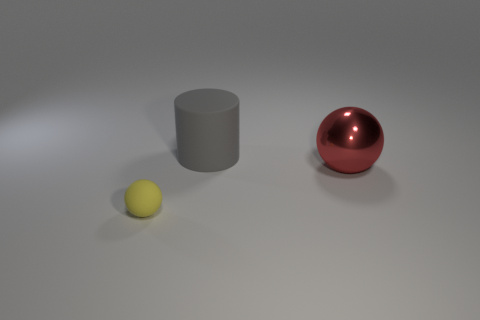Is there any other thing that is the same shape as the gray thing?
Keep it short and to the point. No. Is there anything else that has the same size as the rubber sphere?
Offer a very short reply. No. Are the tiny yellow sphere and the sphere that is on the right side of the small sphere made of the same material?
Keep it short and to the point. No. What color is the thing that is both left of the big red metallic ball and in front of the big gray matte object?
Your answer should be compact. Yellow. How many cubes are either small yellow rubber things or large gray rubber objects?
Your answer should be compact. 0. Is the shape of the tiny yellow rubber thing the same as the thing right of the large matte thing?
Your answer should be compact. Yes. There is a thing that is both right of the yellow sphere and in front of the big gray cylinder; what size is it?
Provide a short and direct response. Large. What shape is the big metal thing?
Offer a terse response. Sphere. There is a rubber object behind the tiny yellow ball; are there any gray things on the right side of it?
Offer a very short reply. No. There is a ball that is behind the yellow object; how many rubber objects are in front of it?
Provide a short and direct response. 1. 